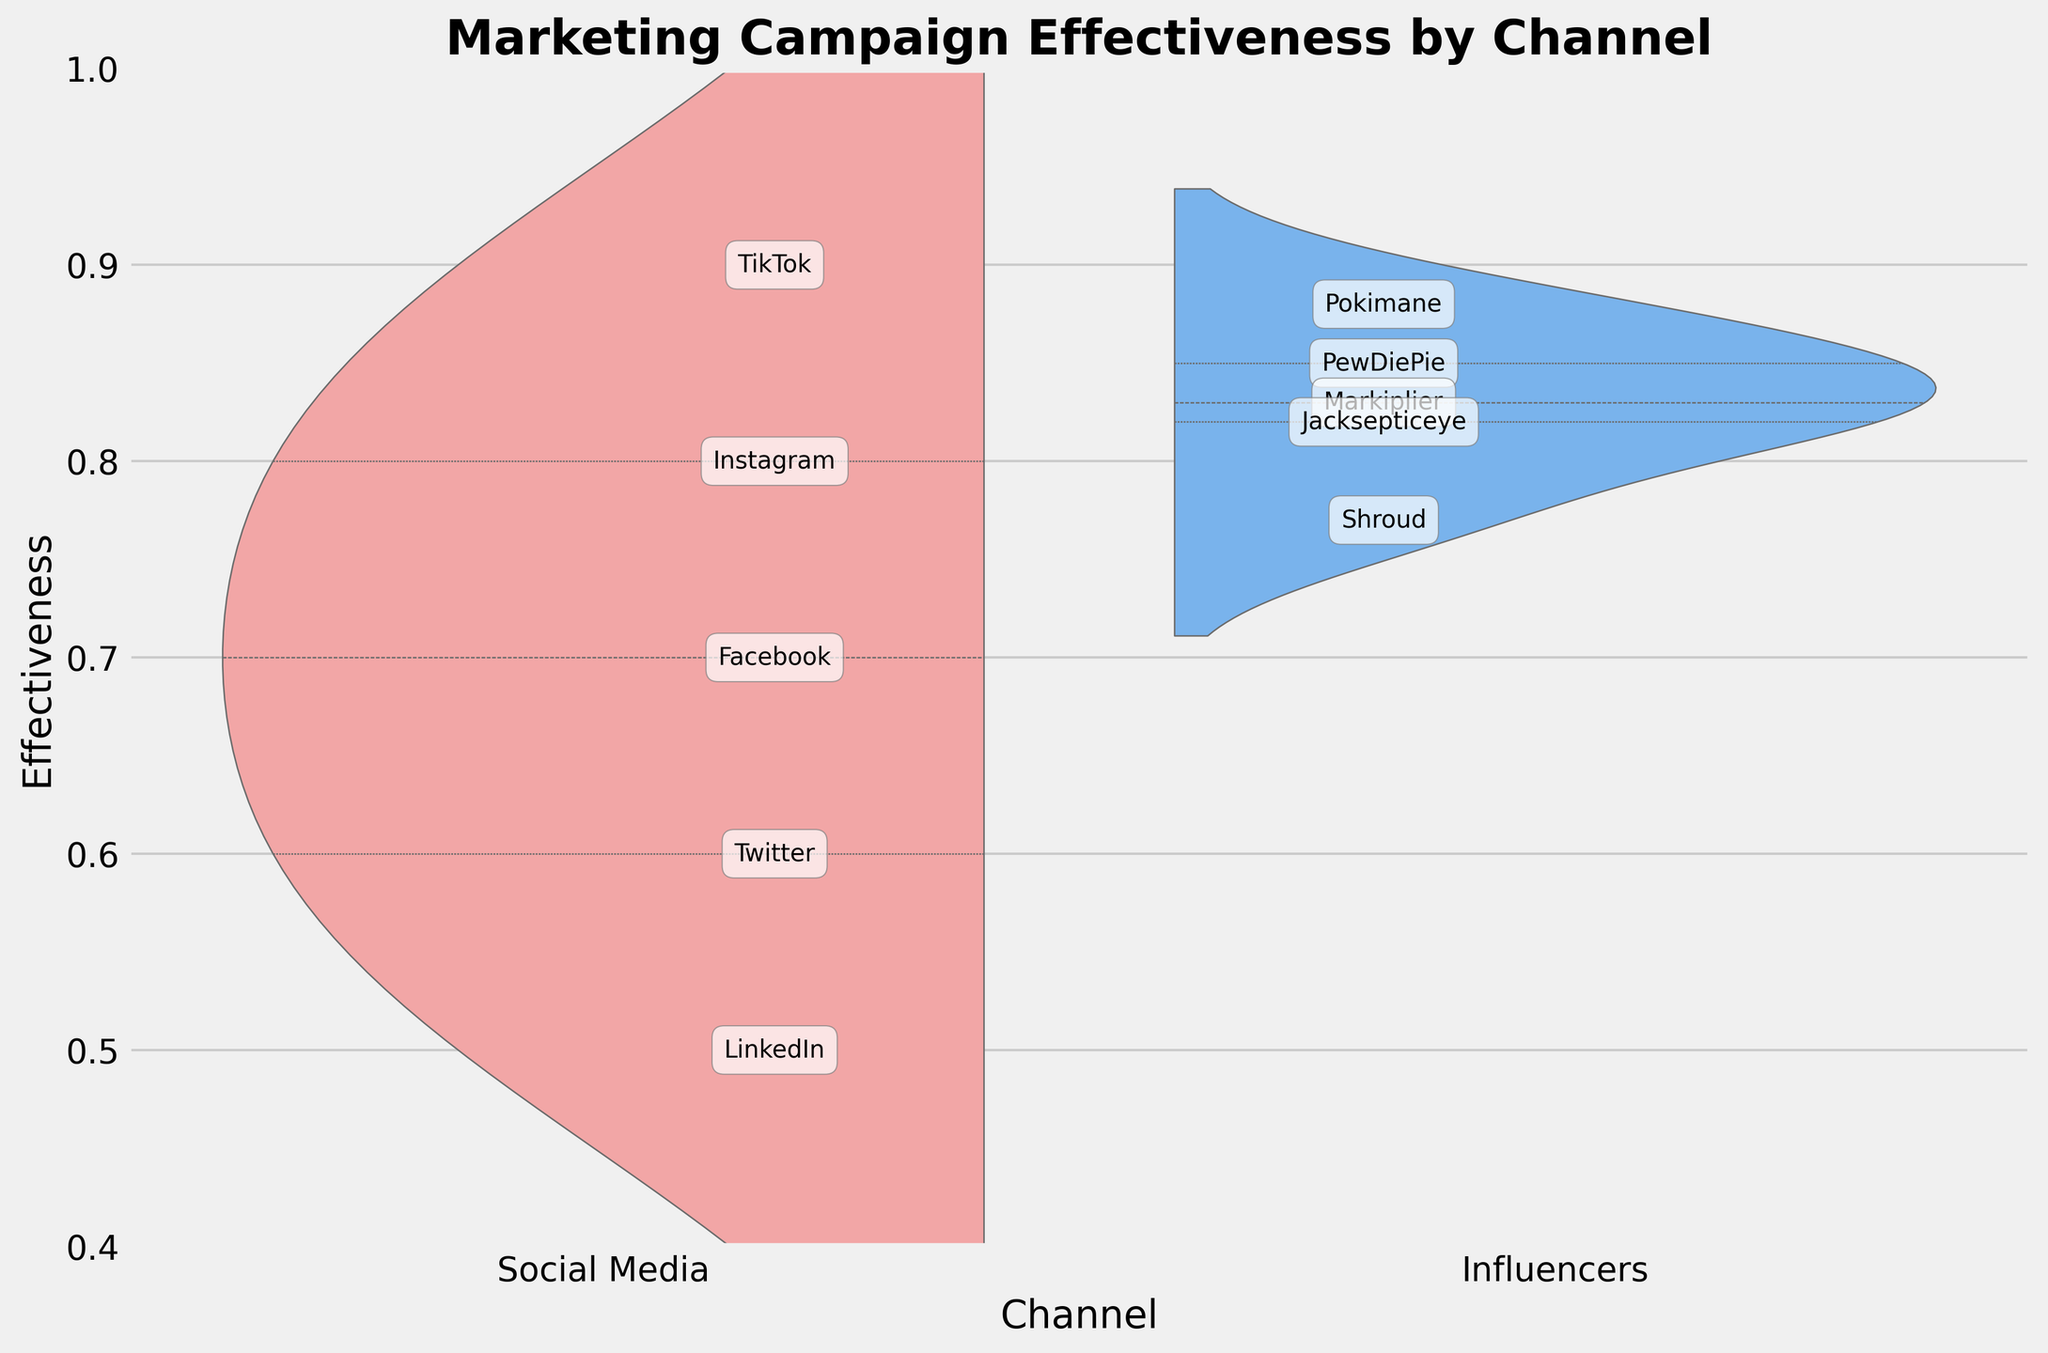what are the two channels represented in the Split Violin Chart? The Split Violin Chart shows two broad sections, each labeled on the x-axis. These labels represent two channels: "Social Media" and "Influencers".
Answer: Social Media and Influencers Which channel has the highest peak effectiveness rating? Looking closely at the peaks of each channel's distribution, the highest value occurs within the "Social Media" channel. The peak effectiveness rating here matches TikTok's effectiveness score of 0.9.
Answer: Social Media What are the range of effectiveness values for the Influencers channel? By observing the values on the y-axis and identifying the span of the distribution for the "Influencers" channel, the values range from Shroud's score of 0.77 to Pokimane's score of 0.88.
Answer: 0.77 to 0.88 How many platforms are evaluated for Social Media? Each annotated point within the "Social Media" section represents a distinct platform. Counting these annotations gives the total number of platforms evaluated for "Social Media".
Answer: 5 What platform has the lowest effectiveness in the Social Media group? Among the Social Media platforms, LinkedIn's effectiveness score is visually positioned at the lowest point, which is 0.5.
Answer: LinkedIn What is the difference in effectiveness between the most effective platform in Social Media and the most effective influencer? TikTok is the most effective platform in Social Media with a score of 0.9, and Pokimane is the most effective influencer with a score of 0.88. The difference is calculated by subtracting 0.88 from 0.9.
Answer: 0.02 Do Influencers or Social Media have more varied effectiveness scores? By examining the overall spread of each distribution, the "Social Media" channel shows values ranging from LinkedIn's 0.5 to TikTok's 0.9, indicating a wider spread compared to the Influencers channel whose values range from 0.77 to 0.88.
Answer: Social Media Which influencer has an effectiveness score closest to 0.8? Within the "Influencers" section, Jacksepticeye has an effectiveness score of 0.82, which is the closest to 0.8 when comparing to other influencers' scores.
Answer: Jacksepticeye How many influencers have effectiveness scores greater than 0.8? Observing the annotations within the "Influencers" channel section, counts of effectiveness scores exceeding 0.8 can be noted: PewDiePie (0.85), Markiplier (0.83), Pokimane (0.88), and Jacksepticeye (0.82). This results in four influencers.
Answer: 4 What can be inferred about the marketing campaign effectiveness based on the chart type? The Split Violin Chart visualizes the density of effectiveness scores for each channel, highlighting the variability and central tendency. "Social Media" demonstrates a broader variability compared to "Influencers", which suggests that the influences of Social Media platforms are more diverse in their effectiveness than individual influencers.
Answer: Social Media demonstrates broader variability 